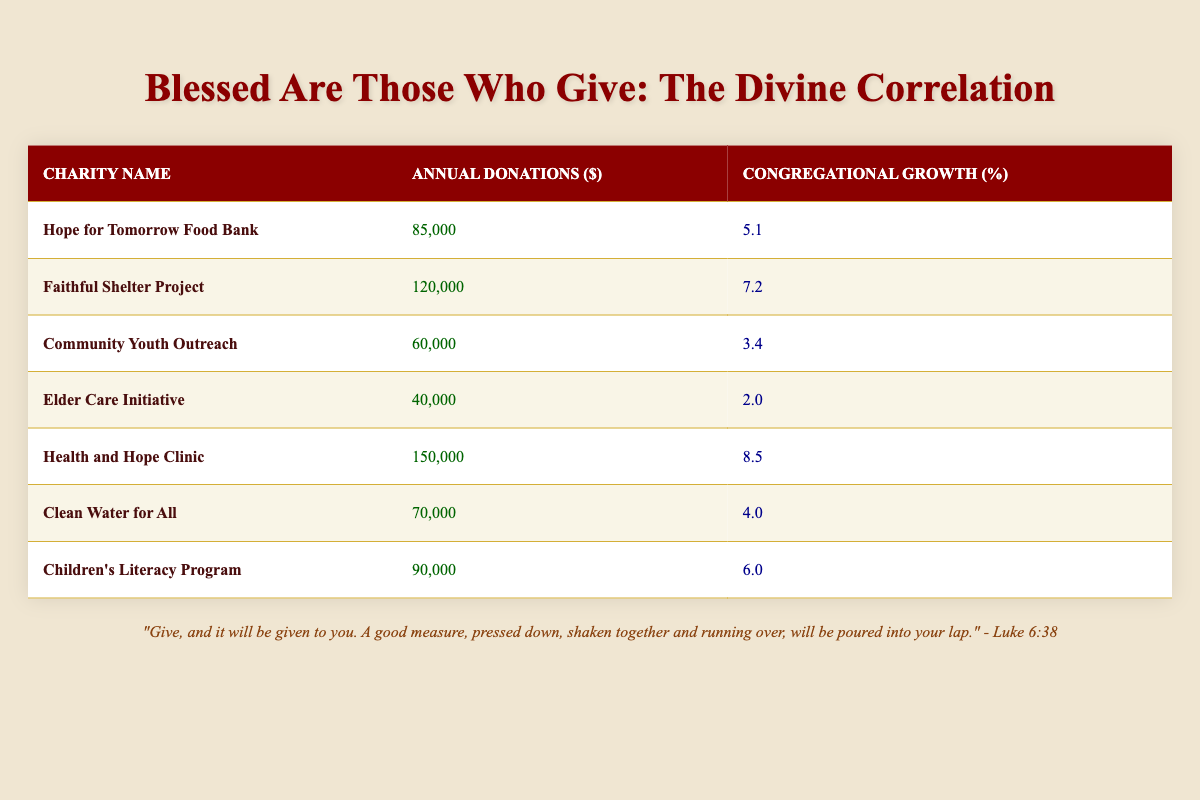What is the annual donation amount of the Hope for Tomorrow Food Bank? The table lists "Hope for Tomorrow Food Bank" in the first row under the "Charity Name" column. The corresponding "Annual Donations" amount is 85,000.
Answer: 85,000 What percentage growth does the Health and Hope Clinic contribute to the congregation? For "Health and Hope Clinic," the table indicates a "Congregational Growth" of 8.5% in the respective column.
Answer: 8.5% Which charity has the lowest donations, and how much is it? The charity with the lowest donations is "Elder Care Initiative," which has annual donations of 40,000, as seen in the table which lists the donations in ascending order.
Answer: Elder Care Initiative; 40,000 What is the average annual donation across all listed charities? To calculate the average, sum the annual donations: 85,000 + 120,000 + 60,000 + 40,000 + 150,000 + 70,000 + 90,000 = 615,000. Since there are 7 charities, divide by 7. Thus, the average is 615,000 / 7 = 87,857.14, rounded to the nearest whole number gives 87,857.
Answer: 87,857 Is the congregational growth of Community Youth Outreach greater than 4%? In the table, "Community Youth Outreach" shows a congregational growth percentage of 3.4%, which is less than 4%. Therefore, the statement is false.
Answer: No Which charity leads to the highest percentage of congregational growth? The table shows "Health and Hope Clinic" with the highest percentage growth of 8.5%. Comparing it to other charities listed, no other percentage is higher.
Answer: Health and Hope Clinic; 8.5% Are the total annual donations of the top three organizations more than 250,000? The top three charities by annual donations are "Health and Hope Clinic" (150,000), "Faithful Shelter Project" (120,000), and "Hope for Tomorrow Food Bank" (85,000). Adding these, we get 150,000 + 120,000 + 85,000 = 355,000, which is more than 250,000.
Answer: Yes What is the difference in congregational growth between the Charity with the highest and the lowest growth? "Health and Hope Clinic" has the highest growth at 8.5%, and "Elder Care Initiative" has the lowest at 2.0%. The difference is calculated by 8.5% - 2.0% = 6.5%.
Answer: 6.5% 